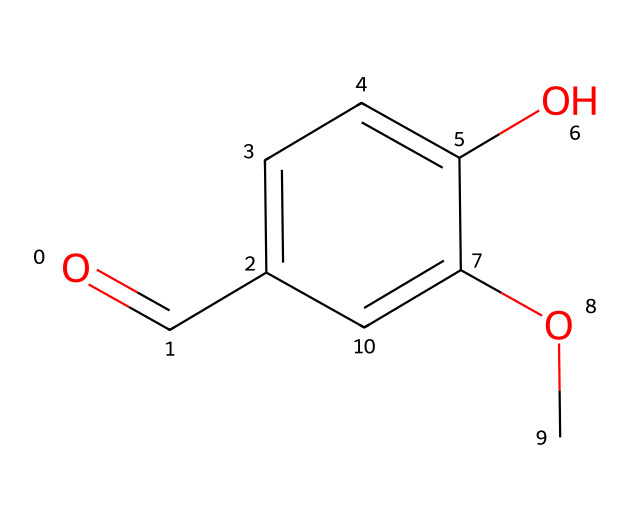What is the functional group present in this compound? The chemical structure contains a carbonyl group (C=O) at the end of the carbon chain, which is characteristic of aldehydes. The oxygen atom (O) double-bonded to the carbon atom indicates this functional group.
Answer: carbonyl How many hydroxyl groups are present? The structure shows a hydroxyl group (–OH) attached to the aromatic ring, which indicates the presence of two such groups because there are two -OH attached to the benzene structure.
Answer: two What is the molecular formula of this compound? To derive the molecular formula, count the types of atoms present in the structure: there are 8 carbon (C) atoms, 8 hydrogen (H) atoms, and 3 oxygen (O) atoms. Therefore, the molecular formula combines these counts: C8H8O3.
Answer: C8H8O3 What type of reaction can this compound undergo due to the aldehyde group? Aldehydes are known to undergo oxidation reactions, commonly converting to carboxylic acids when oxidized. The presence of the aldehyde functional group at the end of the carbon chain allows for this reactivity.
Answer: oxidation Is this compound aromatic? The chemical structure features a benzene ring, which characterizes aromatic compounds. The delocalized electrons within the ring provide the aromatic properties.
Answer: yes How many carbon atoms are in the aromatic ring? The structure shows a six-membered carbon ring where all carbons are part of the aromatic system, leading to the count of 6 carbon atoms within that ring.
Answer: six 